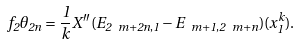<formula> <loc_0><loc_0><loc_500><loc_500>f _ { 2 } \theta _ { 2 n } = \frac { 1 } { k } X ^ { \prime \prime } ( E _ { 2 \ m + 2 n , 1 } - E _ { \ m + 1 , 2 \ m + n } ) ( x _ { 1 } ^ { k } ) .</formula> 